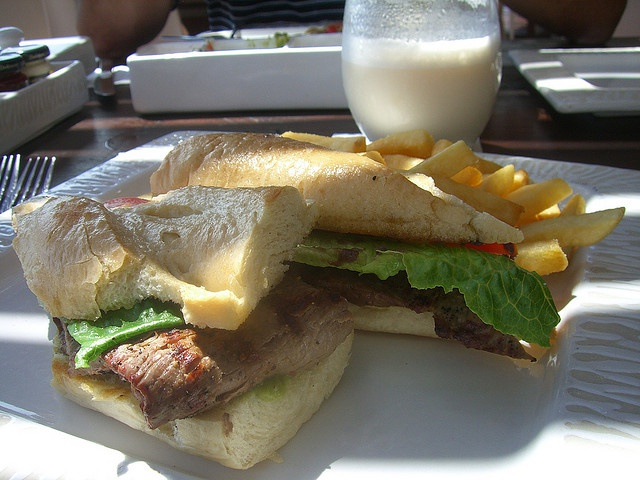Describe the objects in this image and their specific colors. I can see dining table in gray, black, olive, and darkgray tones, sandwich in gray, tan, olive, and darkgray tones, sandwich in gray, olive, black, and darkgreen tones, cup in gray, darkgray, and lightgray tones, and people in gray, black, and maroon tones in this image. 